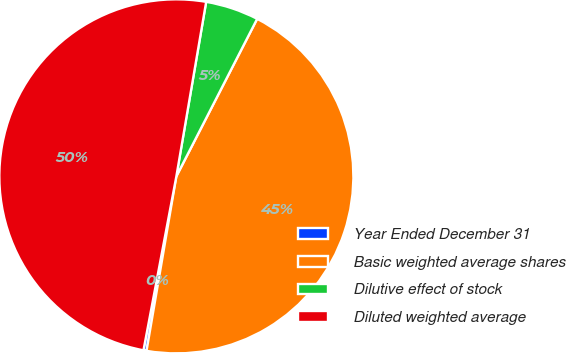Convert chart. <chart><loc_0><loc_0><loc_500><loc_500><pie_chart><fcel>Year Ended December 31<fcel>Basic weighted average shares<fcel>Dilutive effect of stock<fcel>Diluted weighted average<nl><fcel>0.28%<fcel>45.15%<fcel>4.85%<fcel>49.72%<nl></chart> 